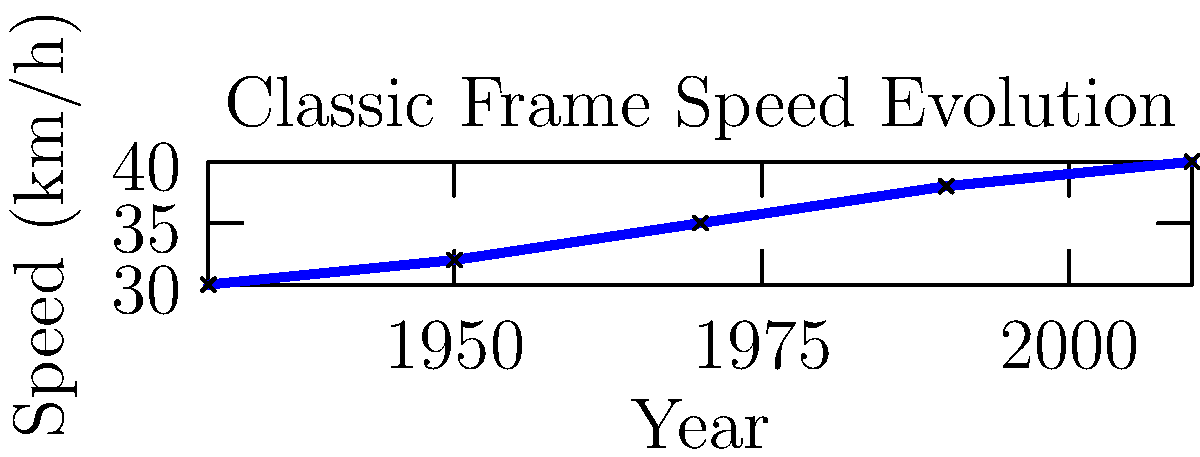As a vintage bicycle enthusiast, you're studying the evolution of classic frame designs. The graph shows the average speed achieved by cyclists using classic frame designs over the years. If this trend continues, what speed (in km/h) would you expect a cyclist using a classic frame design to achieve in 2030? To solve this problem, we'll follow these steps:

1. Observe the trend in the graph:
   The speed increases linearly from 1930 to 2010.

2. Calculate the rate of change:
   Total change in speed: $40 - 30 = 10$ km/h
   Total time period: $2010 - 1930 = 80$ years
   Rate of change: $\frac{10 \text{ km/h}}{80 \text{ years}} = 0.125$ km/h per year

3. Calculate the time difference:
   $2030 - 2010 = 20$ years

4. Calculate the expected speed increase:
   $20 \text{ years} \times 0.125 \text{ km/h/year} = 2.5$ km/h

5. Add the increase to the 2010 speed:
   $40 \text{ km/h} + 2.5 \text{ km/h} = 42.5$ km/h

Therefore, if the trend continues, a cyclist using a classic frame design would be expected to achieve a speed of 42.5 km/h in 2030.
Answer: 42.5 km/h 